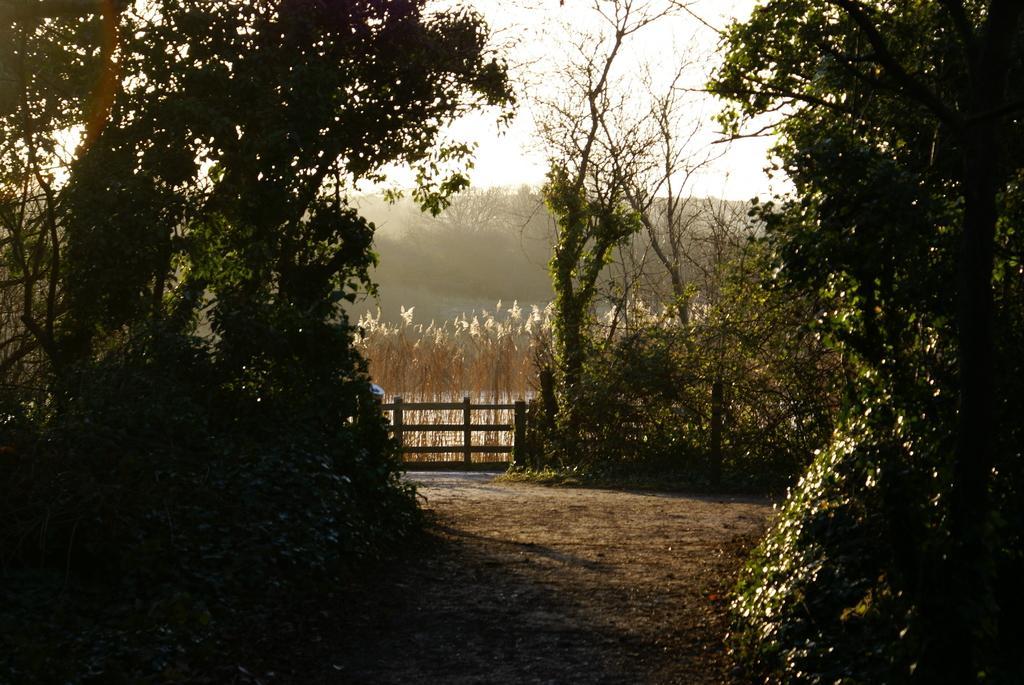Can you describe this image briefly? In this picture I can see there is a walk way here and there are trees on both the sides of the way and in the backdrop I can see there is a fence and a mountain. The sky is clear. 